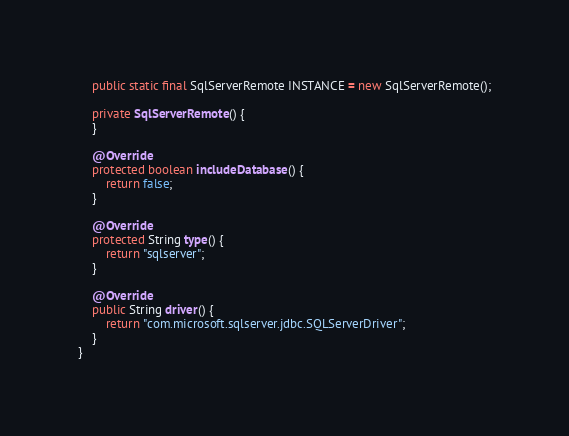<code> <loc_0><loc_0><loc_500><loc_500><_Java_>
    public static final SqlServerRemote INSTANCE = new SqlServerRemote();

    private SqlServerRemote() {
    }

    @Override
    protected boolean includeDatabase() {
        return false;
    }

    @Override
    protected String type() {
        return "sqlserver";
    }

    @Override
    public String driver() {
        return "com.microsoft.sqlserver.jdbc.SQLServerDriver";
    }
}
</code> 